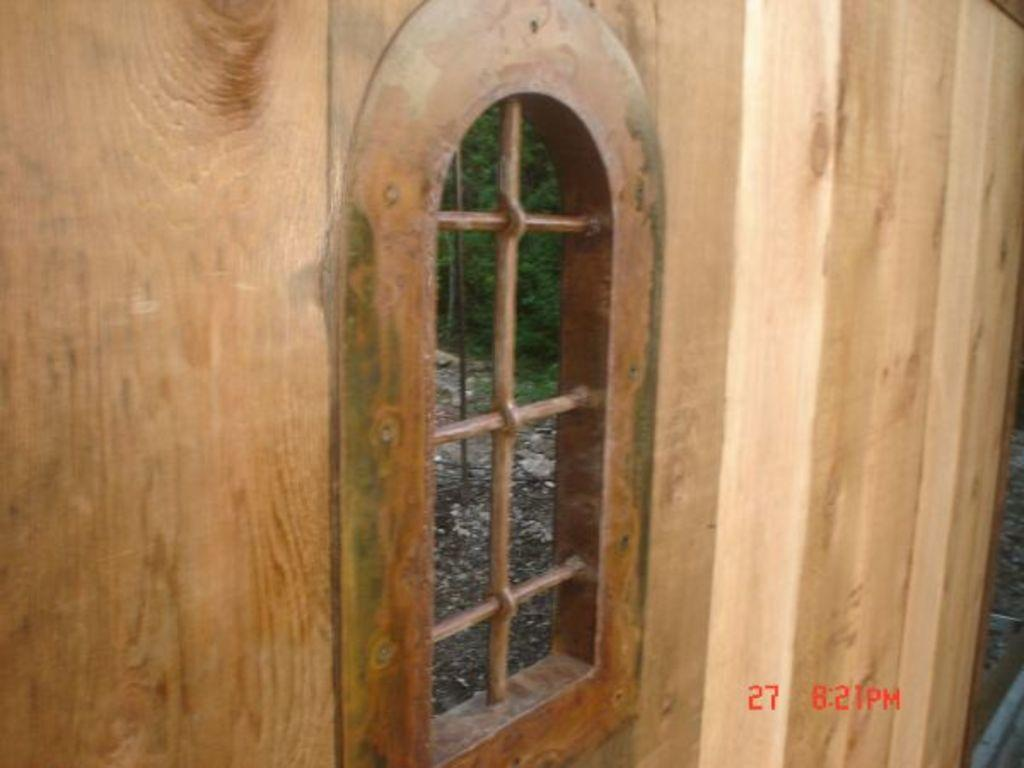What type of structure is present in the image? There is a wooden partition in the image. Can you describe any openings in the wooden partition? There is a window in the image. What can be seen through the window? Trees are visible behind the wooden partition. What other object is present in the image? There is a pole in the image. What type of shirt is hanging on the pole in the image? There is no shirt present in the image; only a wooden partition, a window, trees, and a pole are visible. How many cakes are displayed on the wooden partition in the image? There are no cakes present in the image; only a wooden partition, a window, trees, and a pole are visible. 